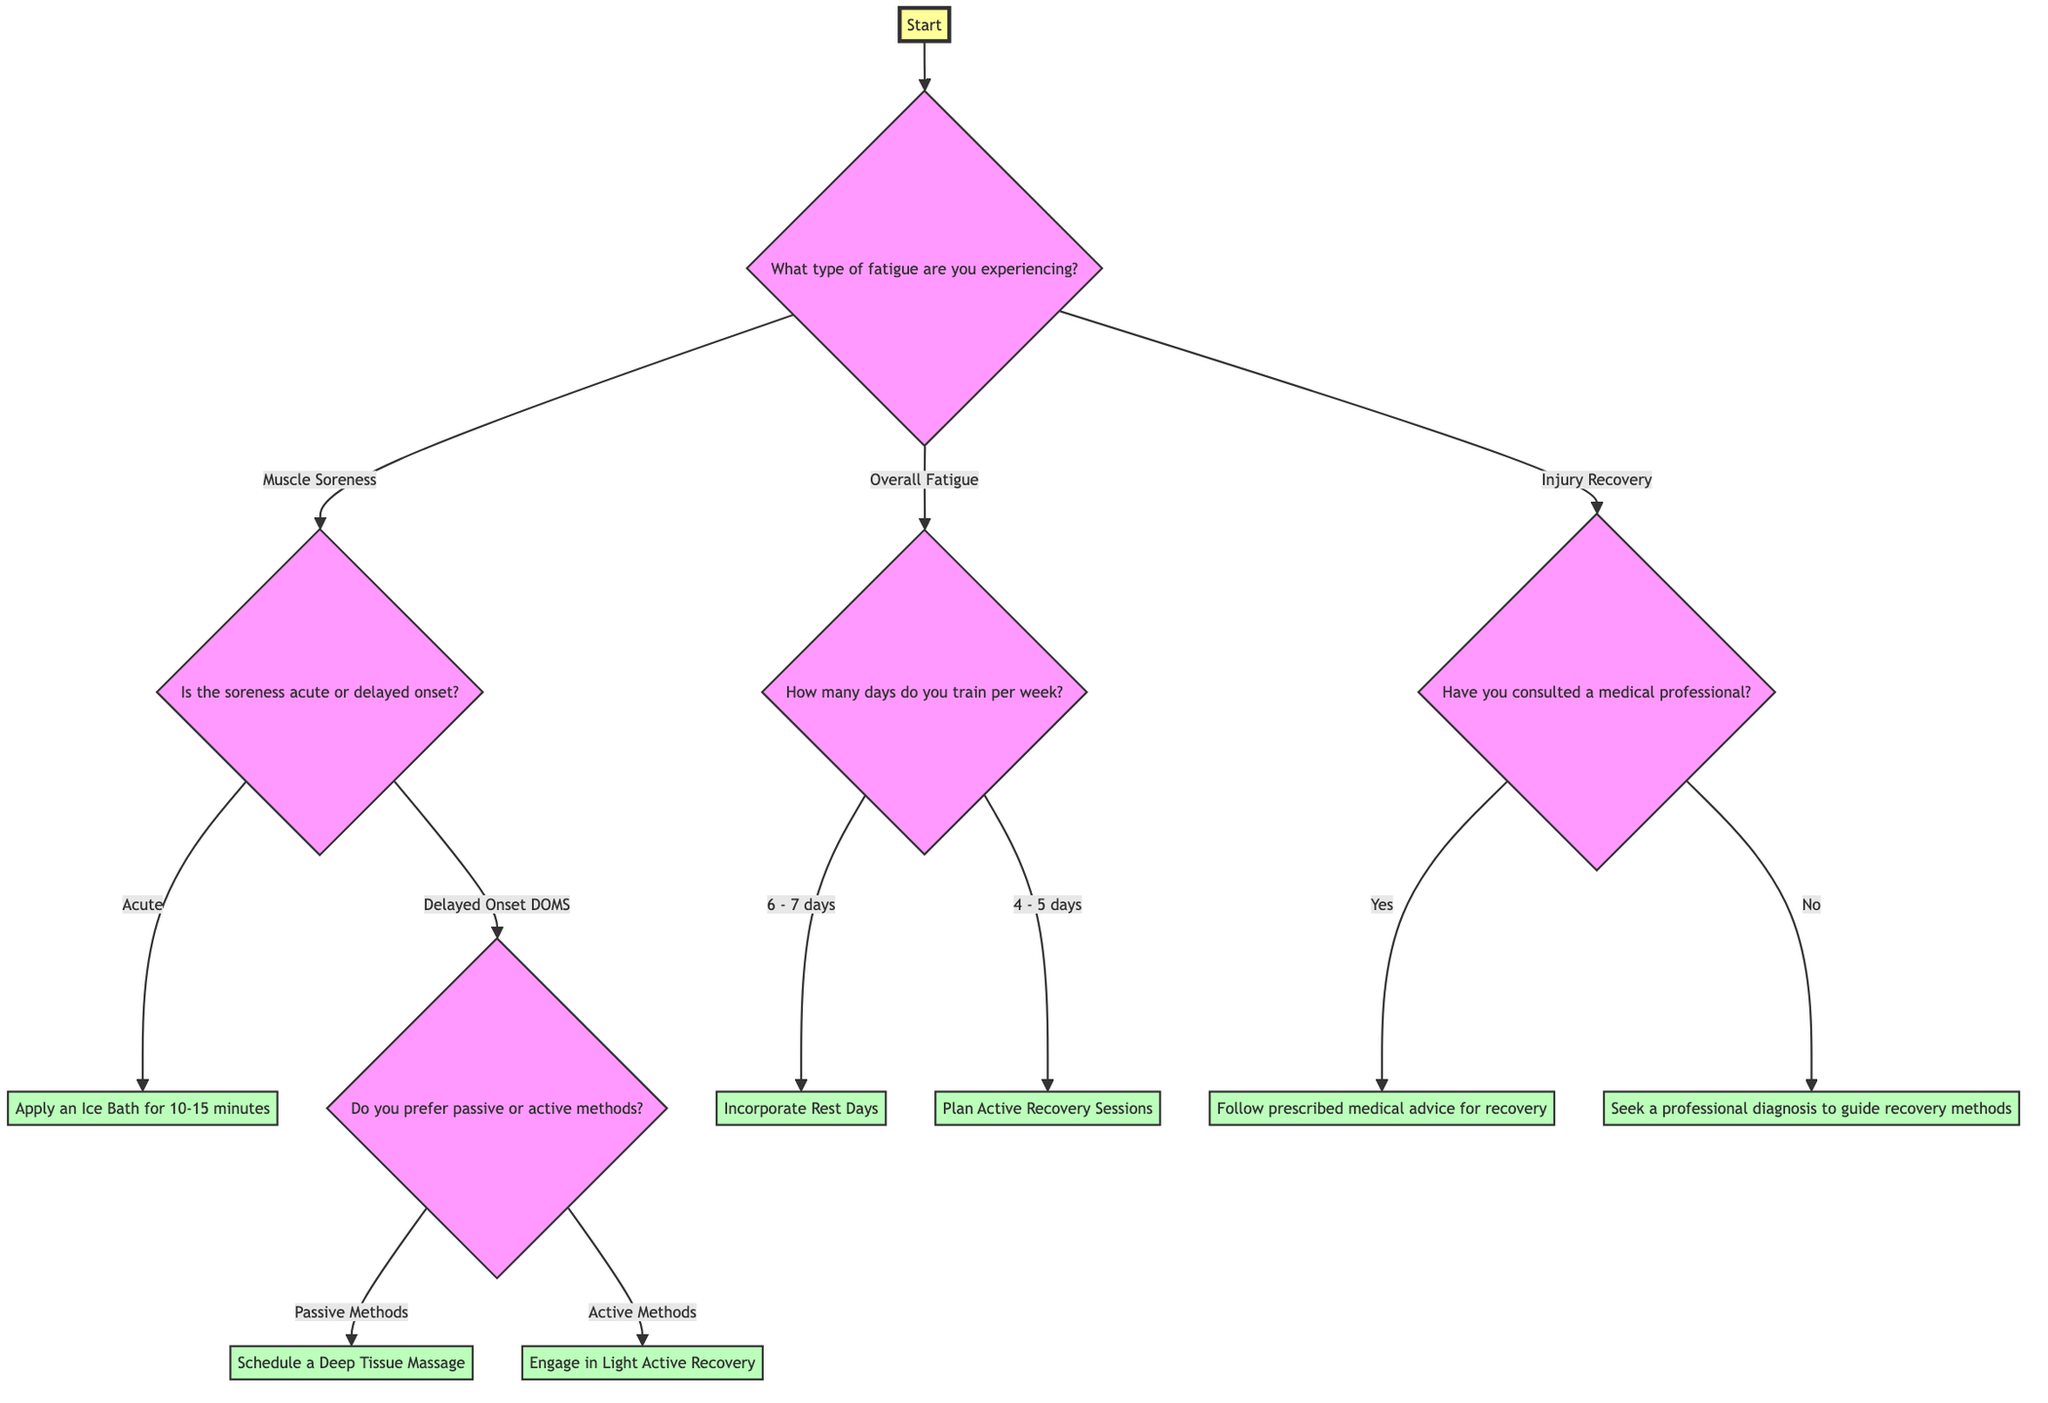What is the first question in the diagram? The first question in the diagram is asked at the "Start" node, which is "What type of fatigue are you experiencing?" This sets the direction for the decision-making process that follows.
Answer: What type of fatigue are you experiencing? How many options are there under "Overall Fatigue"? Under the "Overall Fatigue" node, there are two options: "6 - 7 days" and "4 - 5 days." Each option leads to a different recovery recommendation based on the training frequency.
Answer: 2 options If the soreness is acute, what is the recommendation? The diagram specifies that if the soreness is acute, the recommendation is to "Apply an Ice Bath for 10-15 minutes." This is directly linked to the acute soreness option under the Muscle Soreness category.
Answer: Apply an Ice Bath for 10-15 minutes What happens if the answer to "Have you consulted a medical professional?" is "No"? If the answer is "No," the next step is to "Seek a professional diagnosis to guide recovery methods." This is a direct recommendation based on the decision flow for Injury Recovery.
Answer: Seek a professional diagnosis to guide recovery methods What is the relationship between "Injury Recovery" and "Yes"? "Injury Recovery" leads to the question "Have you consulted a medical professional?" If the answer is "Yes," it further leads to the recommendation "Follow prescribed medical advice for recovery." This shows how the decision tree progresses based on the answer provided.
Answer: Follow prescribed medical advice for recovery If training days are 6-7, what should be incorporated? If the training frequency is 6-7 days a week, the recommendation is to "Incorporate Rest Days (1-2 days of rest)." This ensures that adequate recovery time is factored into the training schedule.
Answer: Incorporate Rest Days (1-2 days of rest) What is the recommendation for someone who prefers active methods for delayed onset soreness? If someone prefers active methods for delayed onset soreness, the recommendation is to "Engage in Light Active Recovery (e.g., walking, swimming)." This is tailored to those who wish to keep moving and remain active while recovering.
Answer: Engage in Light Active Recovery What is the final recommendation if someone trains 4-5 days a week? The recommendation for someone who trains 4-5 days a week is to "Plan Active Recovery Sessions (e.g., yoga, light cycling) on non-training days." This provides a structured way to recover while still remaining active.
Answer: Plan Active Recovery Sessions 